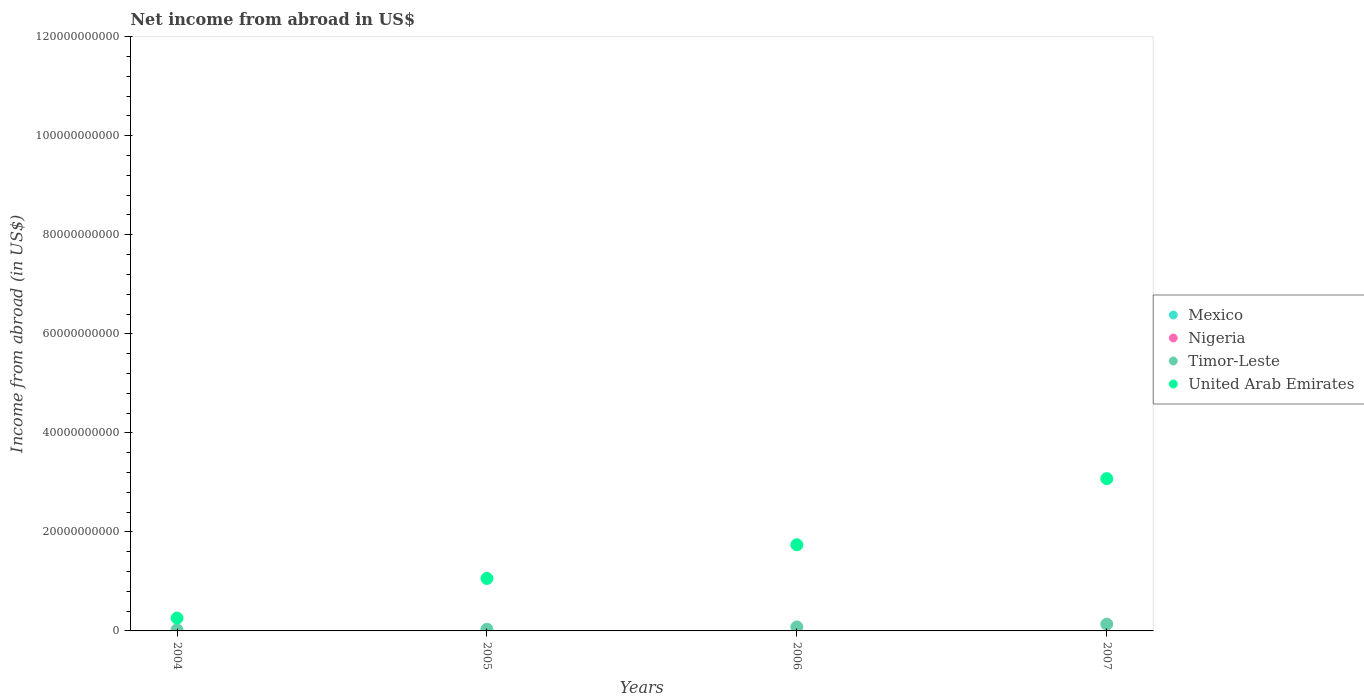How many different coloured dotlines are there?
Offer a very short reply. 2. Is the number of dotlines equal to the number of legend labels?
Make the answer very short. No. What is the net income from abroad in Nigeria in 2006?
Offer a terse response. 0. Across all years, what is the maximum net income from abroad in Timor-Leste?
Give a very brief answer. 1.36e+09. Across all years, what is the minimum net income from abroad in United Arab Emirates?
Give a very brief answer. 2.60e+09. In which year was the net income from abroad in United Arab Emirates maximum?
Provide a short and direct response. 2007. What is the total net income from abroad in Timor-Leste in the graph?
Ensure brevity in your answer.  2.74e+09. What is the difference between the net income from abroad in Timor-Leste in 2005 and that in 2007?
Give a very brief answer. -1.02e+09. What is the difference between the net income from abroad in Nigeria in 2006 and the net income from abroad in Timor-Leste in 2005?
Your answer should be very brief. -3.42e+08. In the year 2004, what is the difference between the net income from abroad in United Arab Emirates and net income from abroad in Timor-Leste?
Keep it short and to the point. 2.38e+09. In how many years, is the net income from abroad in Mexico greater than 104000000000 US$?
Ensure brevity in your answer.  0. What is the ratio of the net income from abroad in Timor-Leste in 2005 to that in 2006?
Your answer should be very brief. 0.42. Is the net income from abroad in Timor-Leste in 2004 less than that in 2005?
Your answer should be very brief. Yes. Is the difference between the net income from abroad in United Arab Emirates in 2005 and 2007 greater than the difference between the net income from abroad in Timor-Leste in 2005 and 2007?
Provide a succinct answer. No. What is the difference between the highest and the second highest net income from abroad in United Arab Emirates?
Offer a very short reply. 1.34e+1. What is the difference between the highest and the lowest net income from abroad in Timor-Leste?
Make the answer very short. 1.14e+09. In how many years, is the net income from abroad in Timor-Leste greater than the average net income from abroad in Timor-Leste taken over all years?
Keep it short and to the point. 2. Is the sum of the net income from abroad in United Arab Emirates in 2004 and 2007 greater than the maximum net income from abroad in Mexico across all years?
Your answer should be compact. Yes. Is it the case that in every year, the sum of the net income from abroad in Nigeria and net income from abroad in Mexico  is greater than the sum of net income from abroad in Timor-Leste and net income from abroad in United Arab Emirates?
Keep it short and to the point. No. Is it the case that in every year, the sum of the net income from abroad in Timor-Leste and net income from abroad in United Arab Emirates  is greater than the net income from abroad in Nigeria?
Offer a very short reply. Yes. Does the net income from abroad in United Arab Emirates monotonically increase over the years?
Your answer should be compact. Yes. Is the net income from abroad in Timor-Leste strictly less than the net income from abroad in Nigeria over the years?
Ensure brevity in your answer.  No. How many dotlines are there?
Your answer should be very brief. 2. Are the values on the major ticks of Y-axis written in scientific E-notation?
Your response must be concise. No. Does the graph contain any zero values?
Offer a terse response. Yes. Where does the legend appear in the graph?
Your answer should be compact. Center right. How are the legend labels stacked?
Provide a short and direct response. Vertical. What is the title of the graph?
Your answer should be compact. Net income from abroad in US$. What is the label or title of the Y-axis?
Offer a terse response. Income from abroad (in US$). What is the Income from abroad (in US$) of Mexico in 2004?
Provide a short and direct response. 0. What is the Income from abroad (in US$) of Timor-Leste in 2004?
Provide a succinct answer. 2.23e+08. What is the Income from abroad (in US$) in United Arab Emirates in 2004?
Offer a very short reply. 2.60e+09. What is the Income from abroad (in US$) of Mexico in 2005?
Your answer should be compact. 0. What is the Income from abroad (in US$) in Nigeria in 2005?
Ensure brevity in your answer.  0. What is the Income from abroad (in US$) in Timor-Leste in 2005?
Make the answer very short. 3.42e+08. What is the Income from abroad (in US$) in United Arab Emirates in 2005?
Make the answer very short. 1.06e+1. What is the Income from abroad (in US$) of Mexico in 2006?
Give a very brief answer. 0. What is the Income from abroad (in US$) in Nigeria in 2006?
Your answer should be very brief. 0. What is the Income from abroad (in US$) of Timor-Leste in 2006?
Your answer should be very brief. 8.07e+08. What is the Income from abroad (in US$) of United Arab Emirates in 2006?
Your response must be concise. 1.74e+1. What is the Income from abroad (in US$) of Mexico in 2007?
Give a very brief answer. 0. What is the Income from abroad (in US$) of Timor-Leste in 2007?
Your answer should be very brief. 1.36e+09. What is the Income from abroad (in US$) in United Arab Emirates in 2007?
Your response must be concise. 3.08e+1. Across all years, what is the maximum Income from abroad (in US$) of Timor-Leste?
Provide a short and direct response. 1.36e+09. Across all years, what is the maximum Income from abroad (in US$) in United Arab Emirates?
Ensure brevity in your answer.  3.08e+1. Across all years, what is the minimum Income from abroad (in US$) in Timor-Leste?
Offer a very short reply. 2.23e+08. Across all years, what is the minimum Income from abroad (in US$) in United Arab Emirates?
Your response must be concise. 2.60e+09. What is the total Income from abroad (in US$) of Mexico in the graph?
Provide a succinct answer. 0. What is the total Income from abroad (in US$) of Nigeria in the graph?
Your answer should be compact. 0. What is the total Income from abroad (in US$) of Timor-Leste in the graph?
Keep it short and to the point. 2.74e+09. What is the total Income from abroad (in US$) of United Arab Emirates in the graph?
Offer a very short reply. 6.14e+1. What is the difference between the Income from abroad (in US$) of Timor-Leste in 2004 and that in 2005?
Give a very brief answer. -1.19e+08. What is the difference between the Income from abroad (in US$) in United Arab Emirates in 2004 and that in 2005?
Give a very brief answer. -8.00e+09. What is the difference between the Income from abroad (in US$) in Timor-Leste in 2004 and that in 2006?
Your answer should be compact. -5.84e+08. What is the difference between the Income from abroad (in US$) in United Arab Emirates in 2004 and that in 2006?
Provide a succinct answer. -1.48e+1. What is the difference between the Income from abroad (in US$) in Timor-Leste in 2004 and that in 2007?
Give a very brief answer. -1.14e+09. What is the difference between the Income from abroad (in US$) of United Arab Emirates in 2004 and that in 2007?
Provide a succinct answer. -2.82e+1. What is the difference between the Income from abroad (in US$) in Timor-Leste in 2005 and that in 2006?
Offer a very short reply. -4.65e+08. What is the difference between the Income from abroad (in US$) of United Arab Emirates in 2005 and that in 2006?
Offer a very short reply. -6.80e+09. What is the difference between the Income from abroad (in US$) in Timor-Leste in 2005 and that in 2007?
Your answer should be compact. -1.02e+09. What is the difference between the Income from abroad (in US$) of United Arab Emirates in 2005 and that in 2007?
Your answer should be very brief. -2.02e+1. What is the difference between the Income from abroad (in US$) in Timor-Leste in 2006 and that in 2007?
Your response must be concise. -5.56e+08. What is the difference between the Income from abroad (in US$) in United Arab Emirates in 2006 and that in 2007?
Make the answer very short. -1.34e+1. What is the difference between the Income from abroad (in US$) in Timor-Leste in 2004 and the Income from abroad (in US$) in United Arab Emirates in 2005?
Offer a very short reply. -1.04e+1. What is the difference between the Income from abroad (in US$) in Timor-Leste in 2004 and the Income from abroad (in US$) in United Arab Emirates in 2006?
Keep it short and to the point. -1.72e+1. What is the difference between the Income from abroad (in US$) of Timor-Leste in 2004 and the Income from abroad (in US$) of United Arab Emirates in 2007?
Give a very brief answer. -3.05e+1. What is the difference between the Income from abroad (in US$) of Timor-Leste in 2005 and the Income from abroad (in US$) of United Arab Emirates in 2006?
Your answer should be compact. -1.71e+1. What is the difference between the Income from abroad (in US$) in Timor-Leste in 2005 and the Income from abroad (in US$) in United Arab Emirates in 2007?
Keep it short and to the point. -3.04e+1. What is the difference between the Income from abroad (in US$) in Timor-Leste in 2006 and the Income from abroad (in US$) in United Arab Emirates in 2007?
Ensure brevity in your answer.  -2.99e+1. What is the average Income from abroad (in US$) of Mexico per year?
Keep it short and to the point. 0. What is the average Income from abroad (in US$) of Timor-Leste per year?
Offer a very short reply. 6.84e+08. What is the average Income from abroad (in US$) of United Arab Emirates per year?
Make the answer very short. 1.53e+1. In the year 2004, what is the difference between the Income from abroad (in US$) in Timor-Leste and Income from abroad (in US$) in United Arab Emirates?
Your answer should be compact. -2.38e+09. In the year 2005, what is the difference between the Income from abroad (in US$) in Timor-Leste and Income from abroad (in US$) in United Arab Emirates?
Offer a terse response. -1.03e+1. In the year 2006, what is the difference between the Income from abroad (in US$) of Timor-Leste and Income from abroad (in US$) of United Arab Emirates?
Ensure brevity in your answer.  -1.66e+1. In the year 2007, what is the difference between the Income from abroad (in US$) of Timor-Leste and Income from abroad (in US$) of United Arab Emirates?
Ensure brevity in your answer.  -2.94e+1. What is the ratio of the Income from abroad (in US$) in Timor-Leste in 2004 to that in 2005?
Make the answer very short. 0.65. What is the ratio of the Income from abroad (in US$) in United Arab Emirates in 2004 to that in 2005?
Offer a terse response. 0.25. What is the ratio of the Income from abroad (in US$) of Timor-Leste in 2004 to that in 2006?
Provide a succinct answer. 0.28. What is the ratio of the Income from abroad (in US$) in United Arab Emirates in 2004 to that in 2006?
Keep it short and to the point. 0.15. What is the ratio of the Income from abroad (in US$) in Timor-Leste in 2004 to that in 2007?
Ensure brevity in your answer.  0.16. What is the ratio of the Income from abroad (in US$) of United Arab Emirates in 2004 to that in 2007?
Offer a terse response. 0.08. What is the ratio of the Income from abroad (in US$) of Timor-Leste in 2005 to that in 2006?
Your response must be concise. 0.42. What is the ratio of the Income from abroad (in US$) of United Arab Emirates in 2005 to that in 2006?
Provide a succinct answer. 0.61. What is the ratio of the Income from abroad (in US$) of Timor-Leste in 2005 to that in 2007?
Ensure brevity in your answer.  0.25. What is the ratio of the Income from abroad (in US$) of United Arab Emirates in 2005 to that in 2007?
Provide a succinct answer. 0.34. What is the ratio of the Income from abroad (in US$) in Timor-Leste in 2006 to that in 2007?
Your answer should be compact. 0.59. What is the ratio of the Income from abroad (in US$) of United Arab Emirates in 2006 to that in 2007?
Your answer should be very brief. 0.57. What is the difference between the highest and the second highest Income from abroad (in US$) in Timor-Leste?
Provide a succinct answer. 5.56e+08. What is the difference between the highest and the second highest Income from abroad (in US$) in United Arab Emirates?
Make the answer very short. 1.34e+1. What is the difference between the highest and the lowest Income from abroad (in US$) of Timor-Leste?
Provide a succinct answer. 1.14e+09. What is the difference between the highest and the lowest Income from abroad (in US$) of United Arab Emirates?
Provide a short and direct response. 2.82e+1. 